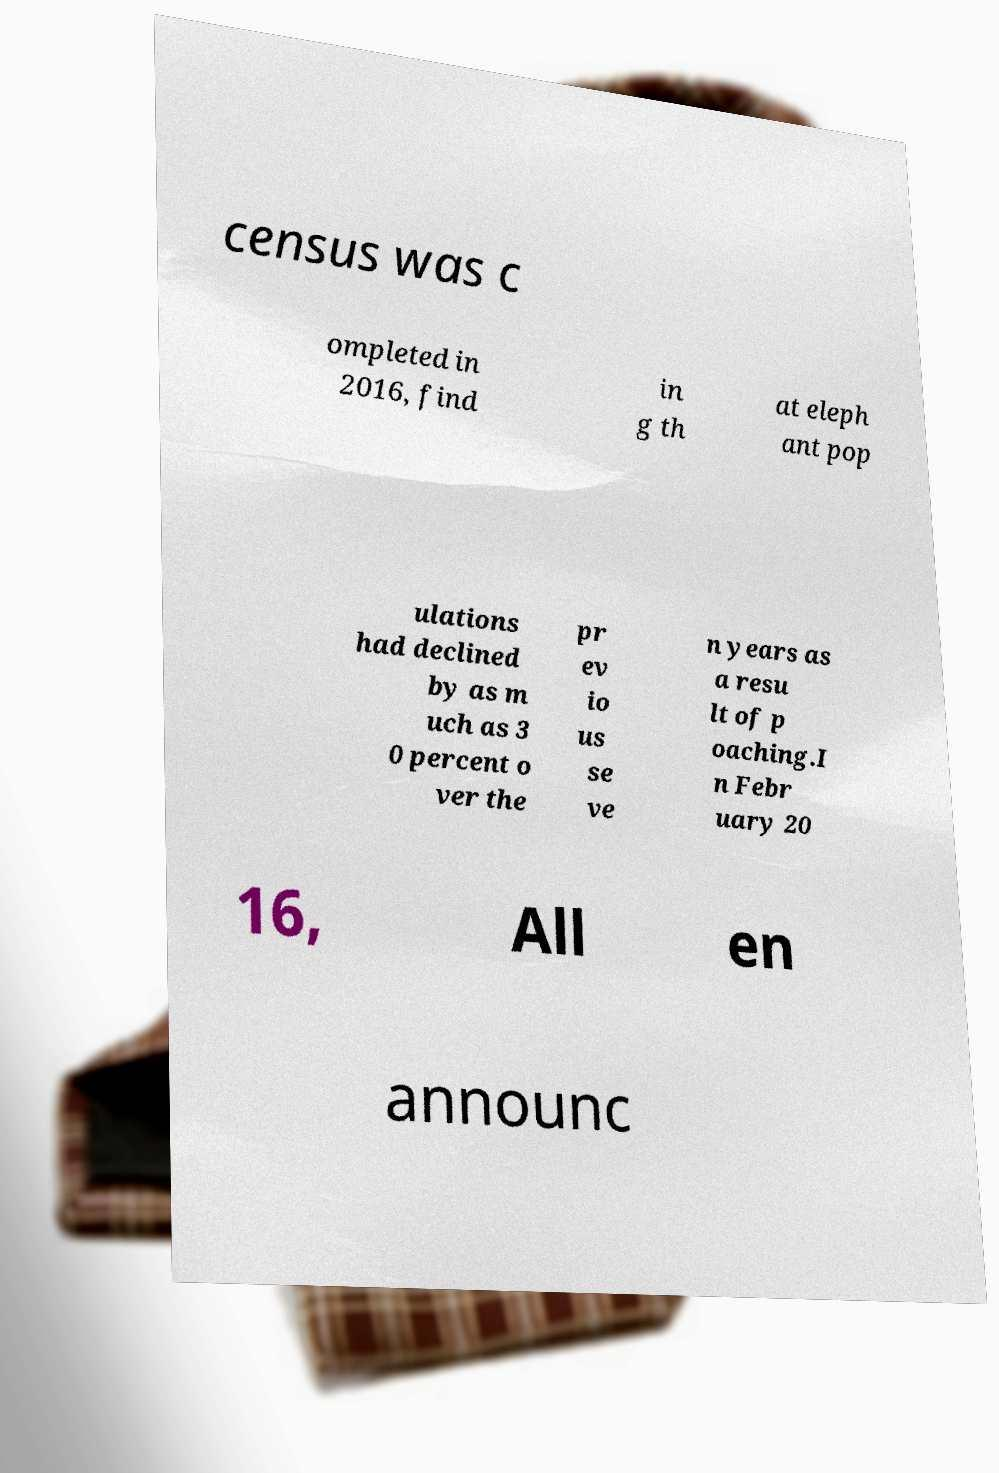There's text embedded in this image that I need extracted. Can you transcribe it verbatim? census was c ompleted in 2016, find in g th at eleph ant pop ulations had declined by as m uch as 3 0 percent o ver the pr ev io us se ve n years as a resu lt of p oaching.I n Febr uary 20 16, All en announc 